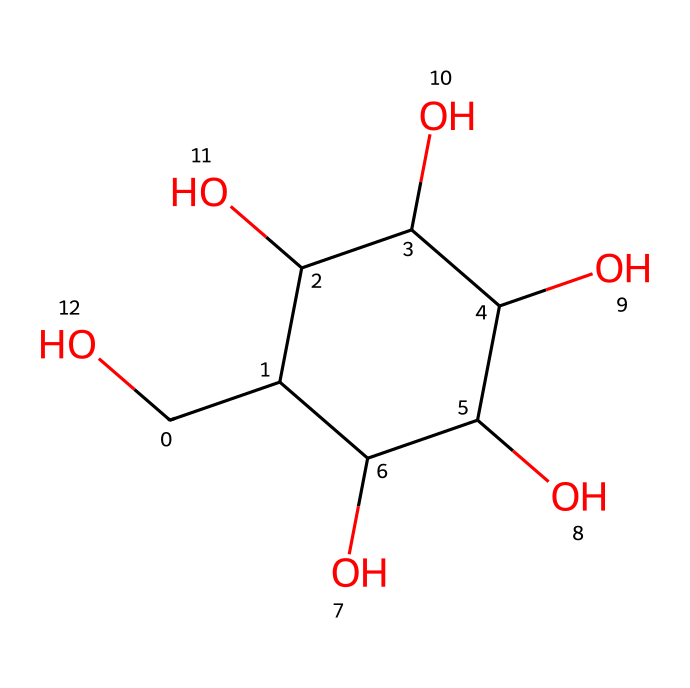what is the molecular formula of the chemical? To find the molecular formula, we need to count the number of each type of atom represented in the SMILES. The structure shows six carbon atoms (C), twelve hydrogen atoms (H), and six oxygen atoms (O), resulting in the formula C6H12O6.
Answer: C6H12O6 how many hydroxyl groups are in the chemical structure? By examining the structure, we can identify the -OH groups (hydroxyl groups). Each oxygen atom connected to a carbon that also has a hydrogen forms a hydroxyl group. The representation indicates that there are six of these -OH groups.
Answer: 6 what type of chemical structure is indicated by this SMILES? The presence of multiple hydroxyl groups in the structure suggests that it is a carbohydrate, specifically a sugar alcohol, due to the typical features of hydroxyl attachments.
Answer: carbohydrate how does this chemical's viscosity change with shear stress? The presence of multiple hydroxyl groups connected to the carbon skeleton allows the molecules to interact less strongly when stress (shear) is applied, therefore the friction within the material decreases under stress, indicating it is a Non-Newtonian fluid.
Answer: decreases why are non-Newtonian fluids beneficial in energy gels? Non-Newtonian fluids can exhibit variable viscosity, meaning they can remain thicker at rest for optimal energy delivery and thin out under stress, facilitating easier absorption during intense activity, which is crucial during matches.
Answer: variable viscosity 